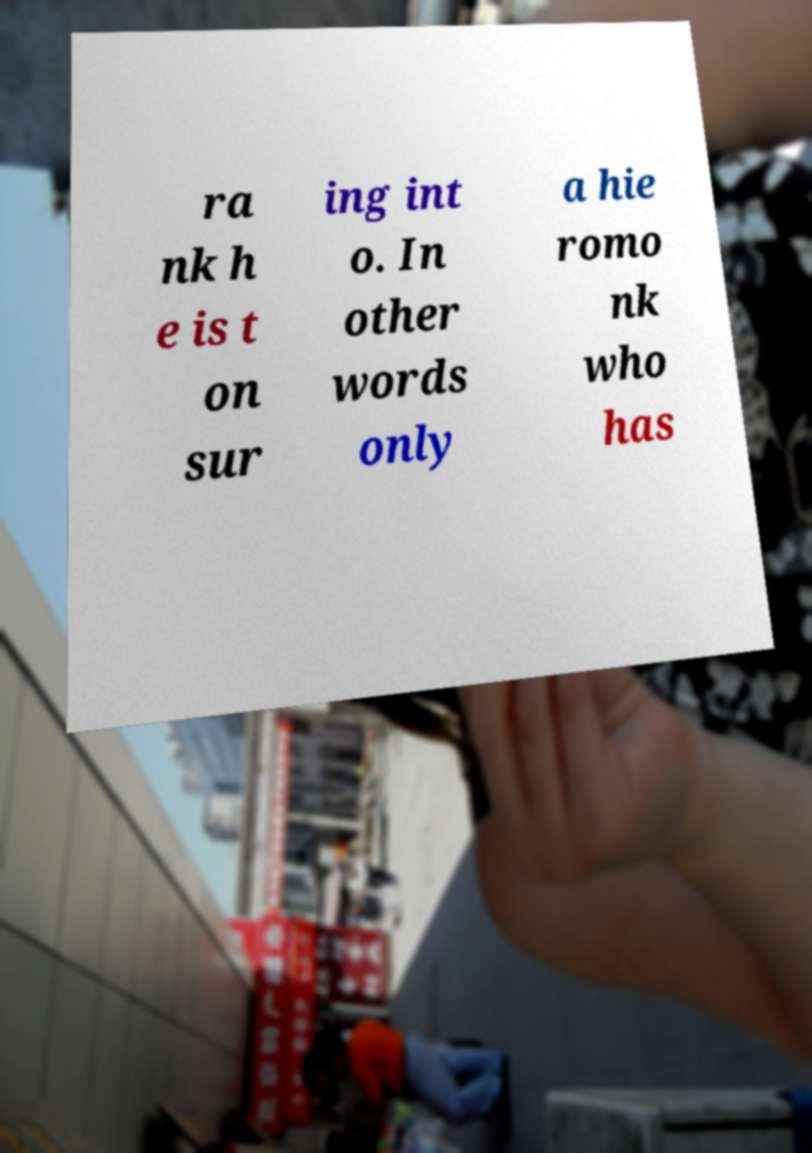Could you assist in decoding the text presented in this image and type it out clearly? ra nk h e is t on sur ing int o. In other words only a hie romo nk who has 